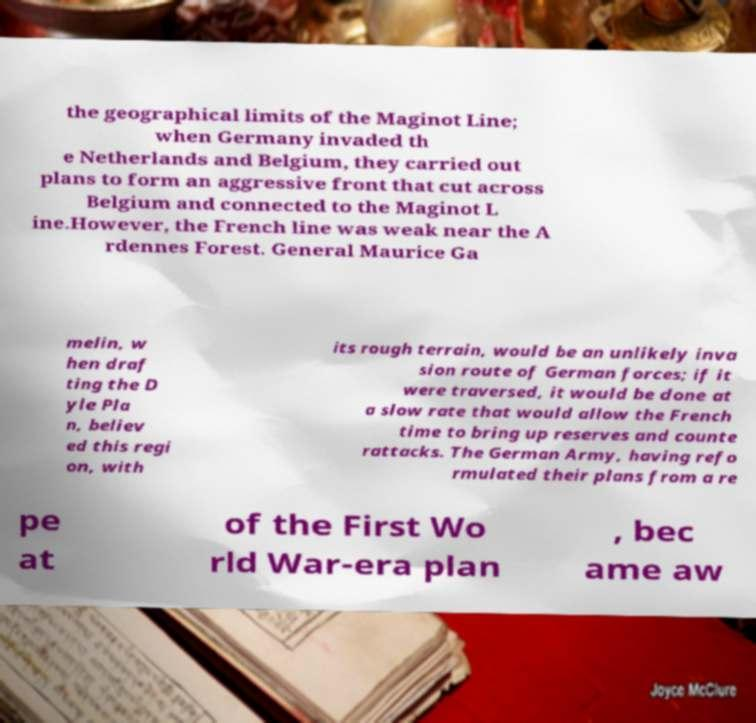What messages or text are displayed in this image? I need them in a readable, typed format. the geographical limits of the Maginot Line; when Germany invaded th e Netherlands and Belgium, they carried out plans to form an aggressive front that cut across Belgium and connected to the Maginot L ine.However, the French line was weak near the A rdennes Forest. General Maurice Ga melin, w hen draf ting the D yle Pla n, believ ed this regi on, with its rough terrain, would be an unlikely inva sion route of German forces; if it were traversed, it would be done at a slow rate that would allow the French time to bring up reserves and counte rattacks. The German Army, having refo rmulated their plans from a re pe at of the First Wo rld War-era plan , bec ame aw 